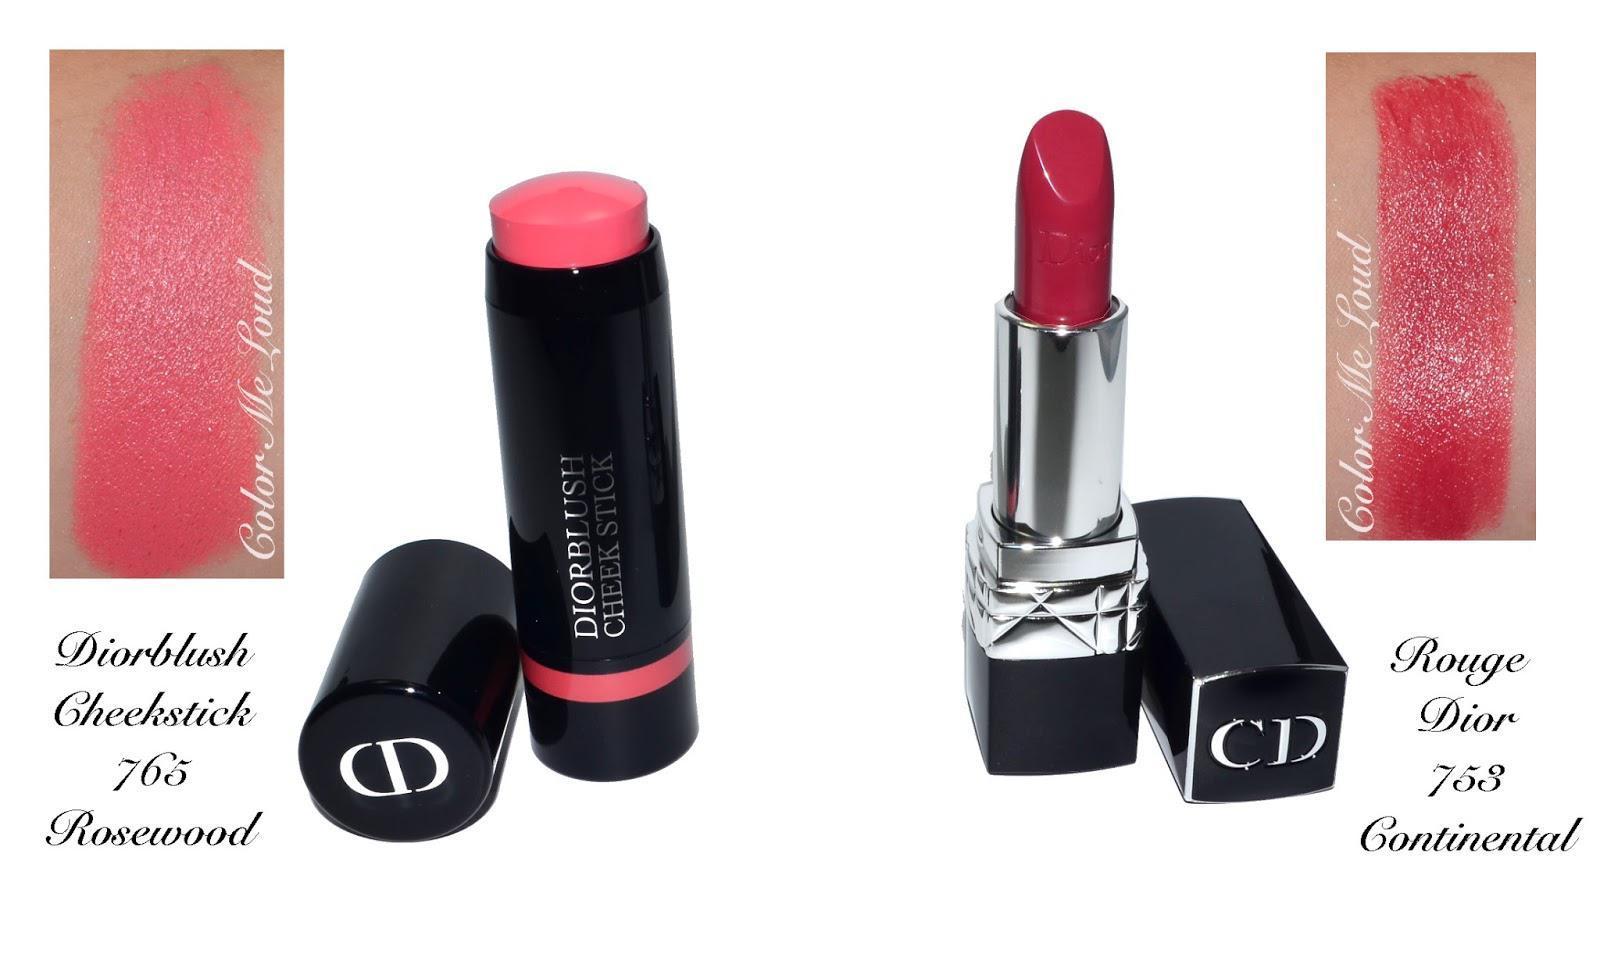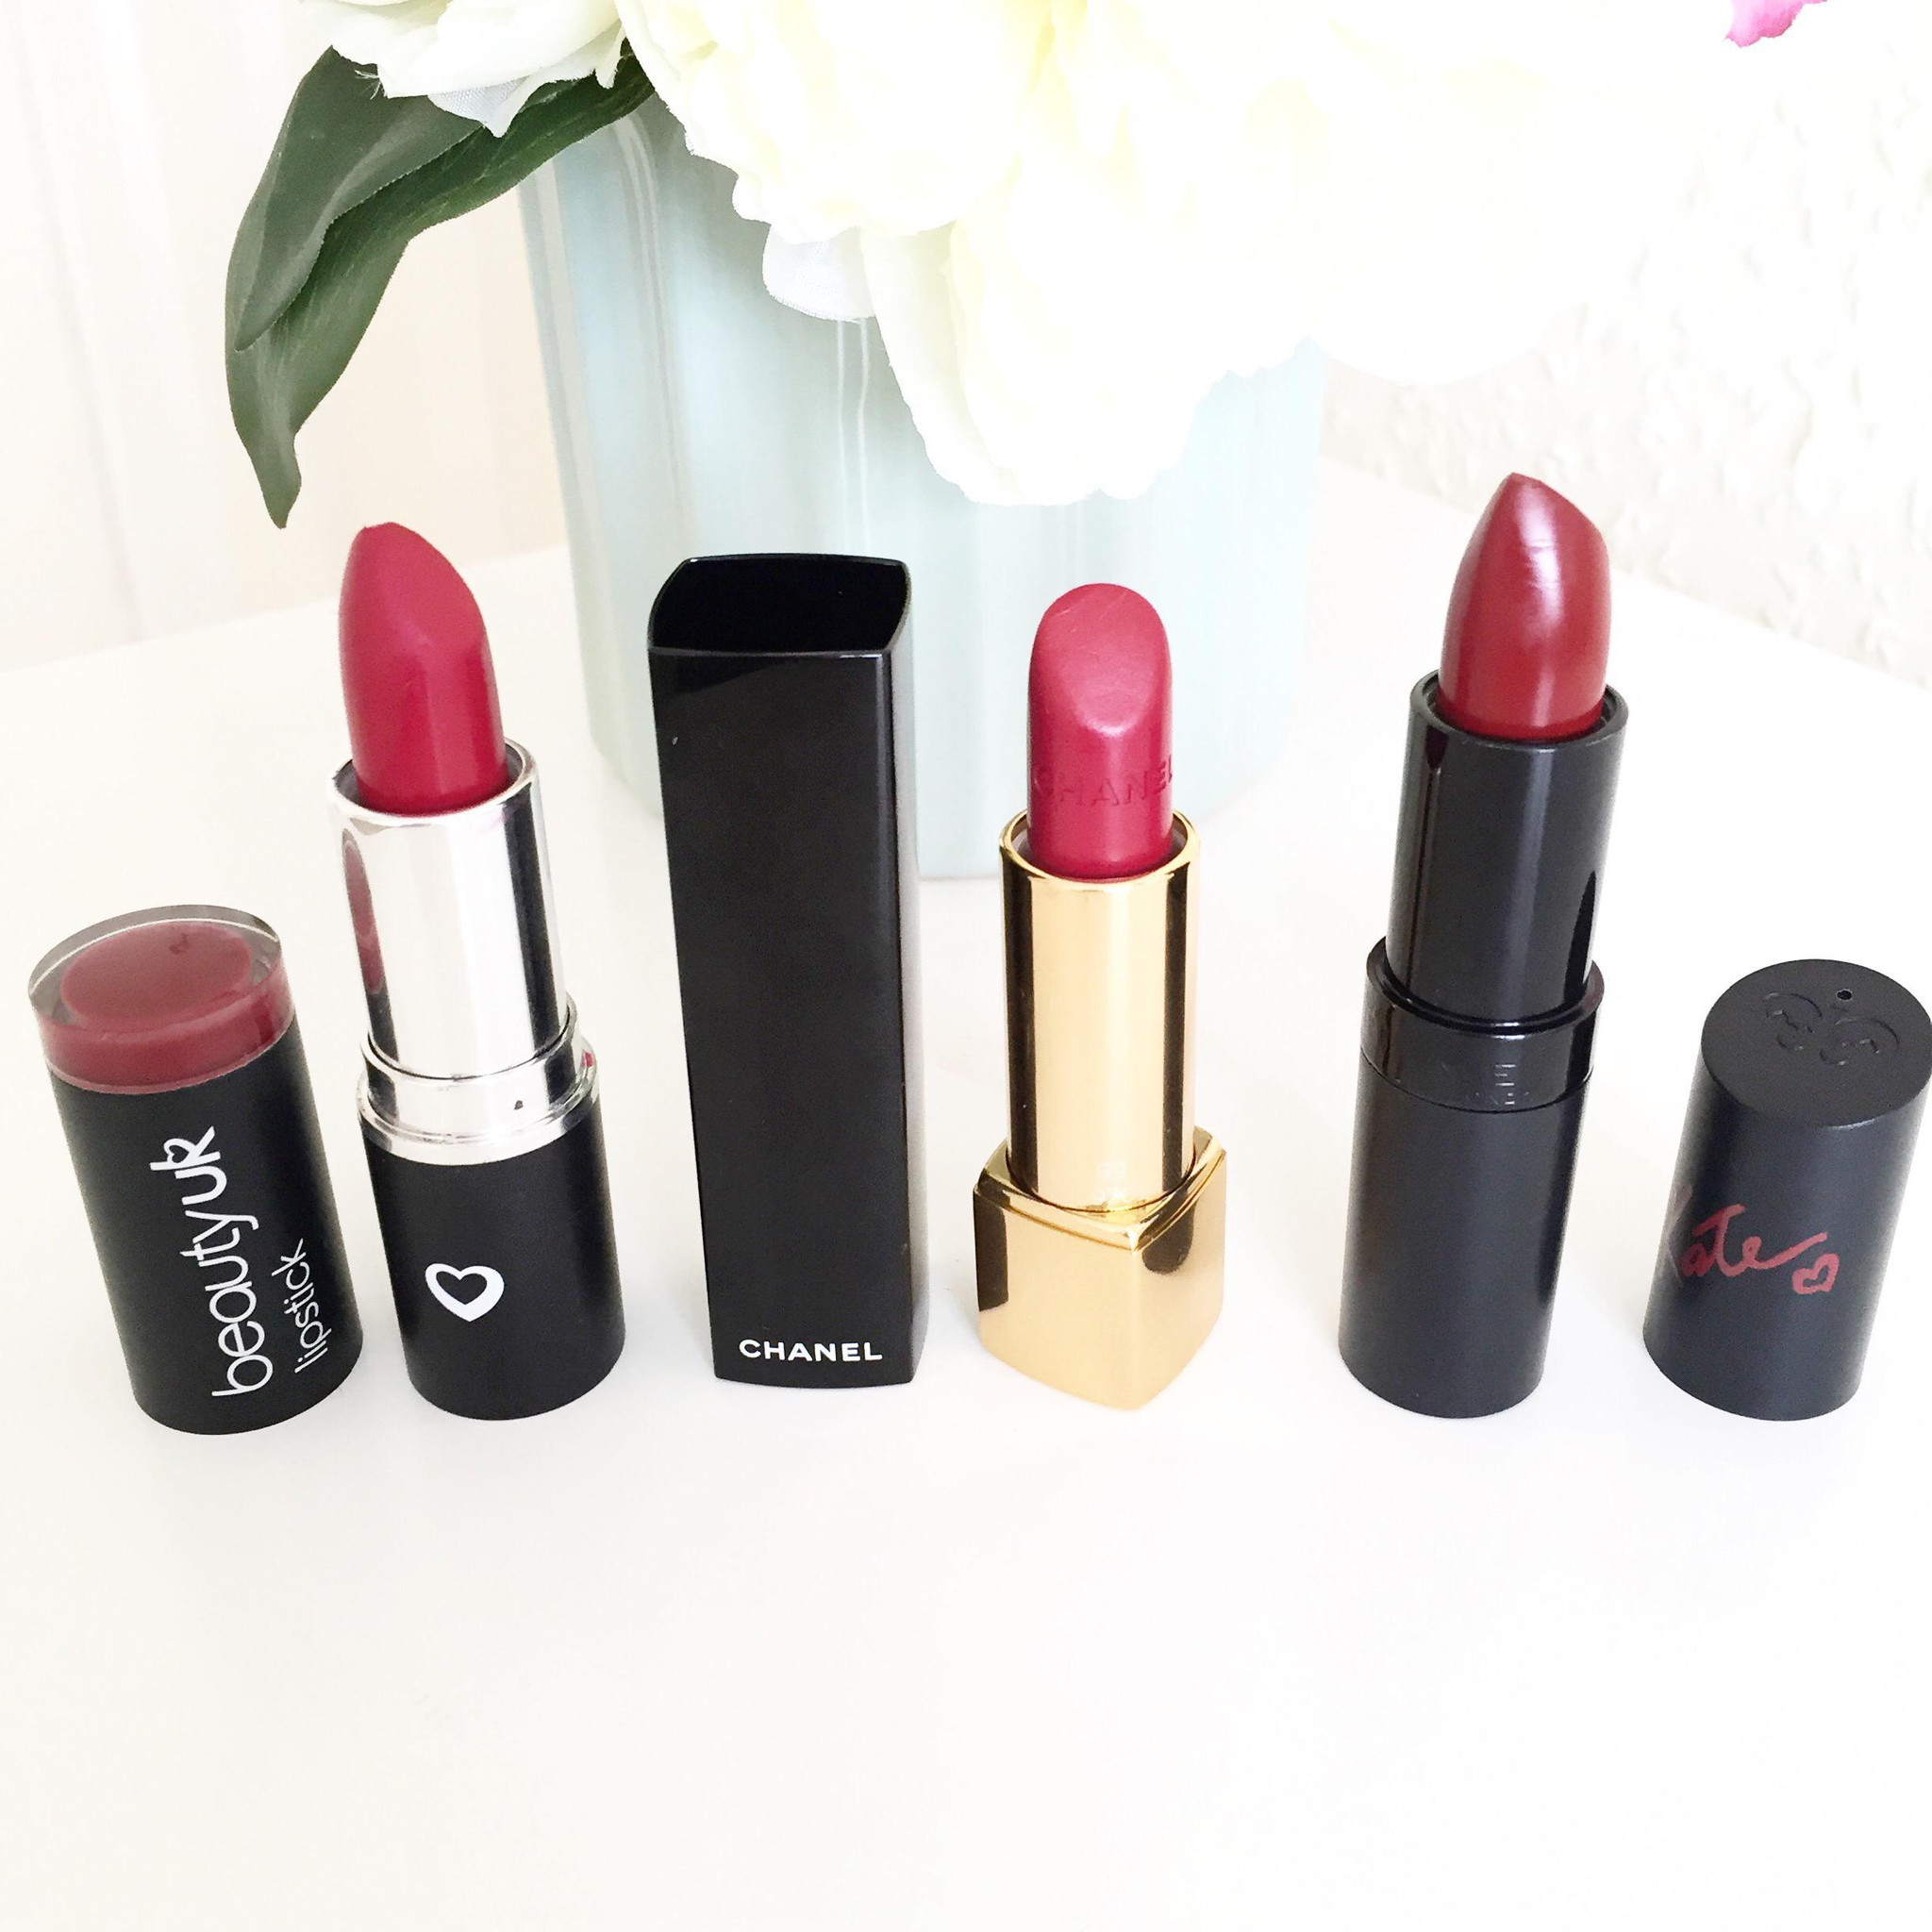The first image is the image on the left, the second image is the image on the right. For the images shown, is this caption "At least one of the images is of Dior lipstick colors" true? Answer yes or no. Yes. The first image is the image on the left, the second image is the image on the right. Evaluate the accuracy of this statement regarding the images: "One of the images has only two makeups, and the". Is it true? Answer yes or no. Yes. 